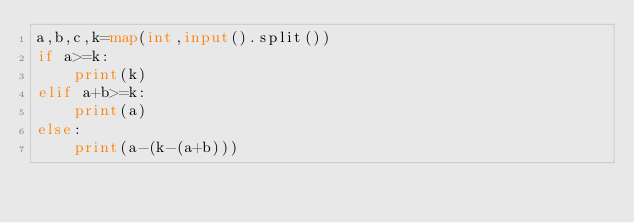Convert code to text. <code><loc_0><loc_0><loc_500><loc_500><_Python_>a,b,c,k=map(int,input().split())
if a>=k:
    print(k)
elif a+b>=k:
    print(a)
else:
    print(a-(k-(a+b)))</code> 